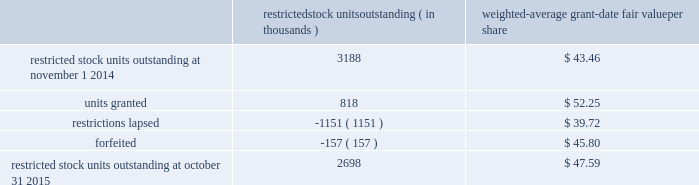Analog devices , inc .
Notes to consolidated financial statements 2014 ( continued ) a summary of the company 2019s restricted stock unit award activity as of october 31 , 2015 and changes during the fiscal year then ended is presented below : restricted stock units outstanding ( in thousands ) weighted- average grant- date fair value per share .
As of october 31 , 2015 , there was $ 108.8 million of total unrecognized compensation cost related to unvested share- based awards comprised of stock options and restricted stock units .
That cost is expected to be recognized over a weighted- average period of 1.3 years .
The total grant-date fair value of shares that vested during fiscal 2015 , 2014 and 2013 was approximately $ 65.6 million , $ 57.4 million and $ 63.9 million , respectively .
Common stock repurchase program the company 2019s common stock repurchase program has been in place since august 2004 .
In the aggregate , the board of directors have authorized the company to repurchase $ 5.6 billion of the company 2019s common stock under the program .
Under the program , the company may repurchase outstanding shares of its common stock from time to time in the open market and through privately negotiated transactions .
Unless terminated earlier by resolution of the company 2019s board of directors , the repurchase program will expire when the company has repurchased all shares authorized under the program .
As of october 31 , 2015 , the company had repurchased a total of approximately 140.7 million shares of its common stock for approximately $ 5.0 billion under this program .
An additional $ 544.5 million remains available for repurchase of shares under the current authorized program .
The repurchased shares are held as authorized but unissued shares of common stock .
The company also , from time to time , repurchases shares in settlement of employee minimum tax withholding obligations due upon the vesting of restricted stock units or the exercise of stock options .
The withholding amount is based on the employees minimum statutory withholding requirement .
Any future common stock repurchases will be dependent upon several factors , including the company's financial performance , outlook , liquidity and the amount of cash the company has available in the united states .
Preferred stock the company has 471934 authorized shares of $ 1.00 par value preferred stock , none of which is issued or outstanding .
The board of directors is authorized to fix designations , relative rights , preferences and limitations on the preferred stock at the time of issuance .
Industry , segment and geographic information the company operates and tracks its results in one reportable segment based on the aggregation of six operating segments .
The company designs , develops , manufactures and markets a broad range of integrated circuits ( ics ) .
The chief executive officer has been identified as the company's chief operating decision maker .
The company has determined that all of the company's operating segments share the following similar economic characteristics , and therefore meet the criteria established for operating segments to be aggregated into one reportable segment , namely : 2022 the primary source of revenue for each operating segment is the sale of integrated circuits .
2022 the integrated circuits sold by each of the company's operating segments are manufactured using similar semiconductor manufacturing processes and raw materials in either the company 2019s own production facilities or by third-party wafer fabricators using proprietary processes .
2022 the company sells its products to tens of thousands of customers worldwide .
Many of these customers use products spanning all operating segments in a wide range of applications .
2022 the integrated circuits marketed by each of the company's operating segments are sold globally through a direct sales force , third-party distributors , independent sales representatives and via our website to the same types of customers .
All of the company's operating segments share a similar long-term financial model as they have similar economic characteristics .
The causes for variation in operating and financial performance are the same among the company's operating segments and include factors such as ( i ) life cycle and price and cost fluctuations , ( ii ) number of competitors , ( iii ) product .
What was the total amount of money set aside from the market cap for restricted stock in 2014? 
Rationale: to find out the answer one must realize when the question talks about market cap one must multiple the share price by the amount of shares . therefore in order to find the amount of money withheld one has to multiple the amount of shares withheld at the average share price .
Computations: (3188 * 43.46)
Answer: 138550.48. Analog devices , inc .
Notes to consolidated financial statements 2014 ( continued ) a summary of the company 2019s restricted stock unit award activity as of october 31 , 2015 and changes during the fiscal year then ended is presented below : restricted stock units outstanding ( in thousands ) weighted- average grant- date fair value per share .
As of october 31 , 2015 , there was $ 108.8 million of total unrecognized compensation cost related to unvested share- based awards comprised of stock options and restricted stock units .
That cost is expected to be recognized over a weighted- average period of 1.3 years .
The total grant-date fair value of shares that vested during fiscal 2015 , 2014 and 2013 was approximately $ 65.6 million , $ 57.4 million and $ 63.9 million , respectively .
Common stock repurchase program the company 2019s common stock repurchase program has been in place since august 2004 .
In the aggregate , the board of directors have authorized the company to repurchase $ 5.6 billion of the company 2019s common stock under the program .
Under the program , the company may repurchase outstanding shares of its common stock from time to time in the open market and through privately negotiated transactions .
Unless terminated earlier by resolution of the company 2019s board of directors , the repurchase program will expire when the company has repurchased all shares authorized under the program .
As of october 31 , 2015 , the company had repurchased a total of approximately 140.7 million shares of its common stock for approximately $ 5.0 billion under this program .
An additional $ 544.5 million remains available for repurchase of shares under the current authorized program .
The repurchased shares are held as authorized but unissued shares of common stock .
The company also , from time to time , repurchases shares in settlement of employee minimum tax withholding obligations due upon the vesting of restricted stock units or the exercise of stock options .
The withholding amount is based on the employees minimum statutory withholding requirement .
Any future common stock repurchases will be dependent upon several factors , including the company's financial performance , outlook , liquidity and the amount of cash the company has available in the united states .
Preferred stock the company has 471934 authorized shares of $ 1.00 par value preferred stock , none of which is issued or outstanding .
The board of directors is authorized to fix designations , relative rights , preferences and limitations on the preferred stock at the time of issuance .
Industry , segment and geographic information the company operates and tracks its results in one reportable segment based on the aggregation of six operating segments .
The company designs , develops , manufactures and markets a broad range of integrated circuits ( ics ) .
The chief executive officer has been identified as the company's chief operating decision maker .
The company has determined that all of the company's operating segments share the following similar economic characteristics , and therefore meet the criteria established for operating segments to be aggregated into one reportable segment , namely : 2022 the primary source of revenue for each operating segment is the sale of integrated circuits .
2022 the integrated circuits sold by each of the company's operating segments are manufactured using similar semiconductor manufacturing processes and raw materials in either the company 2019s own production facilities or by third-party wafer fabricators using proprietary processes .
2022 the company sells its products to tens of thousands of customers worldwide .
Many of these customers use products spanning all operating segments in a wide range of applications .
2022 the integrated circuits marketed by each of the company's operating segments are sold globally through a direct sales force , third-party distributors , independent sales representatives and via our website to the same types of customers .
All of the company's operating segments share a similar long-term financial model as they have similar economic characteristics .
The causes for variation in operating and financial performance are the same among the company's operating segments and include factors such as ( i ) life cycle and price and cost fluctuations , ( ii ) number of competitors , ( iii ) product .
What percent of the restricted stock was lost due to restrictions lapsed in the 2014 period? 
Rationale: to find the percentage lost one must divide the total number restrictions lapsed of restricted stocks by the total number of restricted stock .
Computations: (1151 / 3188)
Answer: 0.36104. 